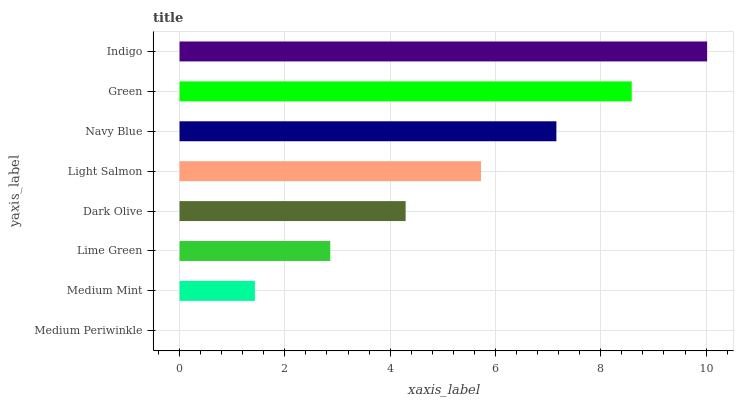Is Medium Periwinkle the minimum?
Answer yes or no. Yes. Is Indigo the maximum?
Answer yes or no. Yes. Is Medium Mint the minimum?
Answer yes or no. No. Is Medium Mint the maximum?
Answer yes or no. No. Is Medium Mint greater than Medium Periwinkle?
Answer yes or no. Yes. Is Medium Periwinkle less than Medium Mint?
Answer yes or no. Yes. Is Medium Periwinkle greater than Medium Mint?
Answer yes or no. No. Is Medium Mint less than Medium Periwinkle?
Answer yes or no. No. Is Light Salmon the high median?
Answer yes or no. Yes. Is Dark Olive the low median?
Answer yes or no. Yes. Is Green the high median?
Answer yes or no. No. Is Navy Blue the low median?
Answer yes or no. No. 